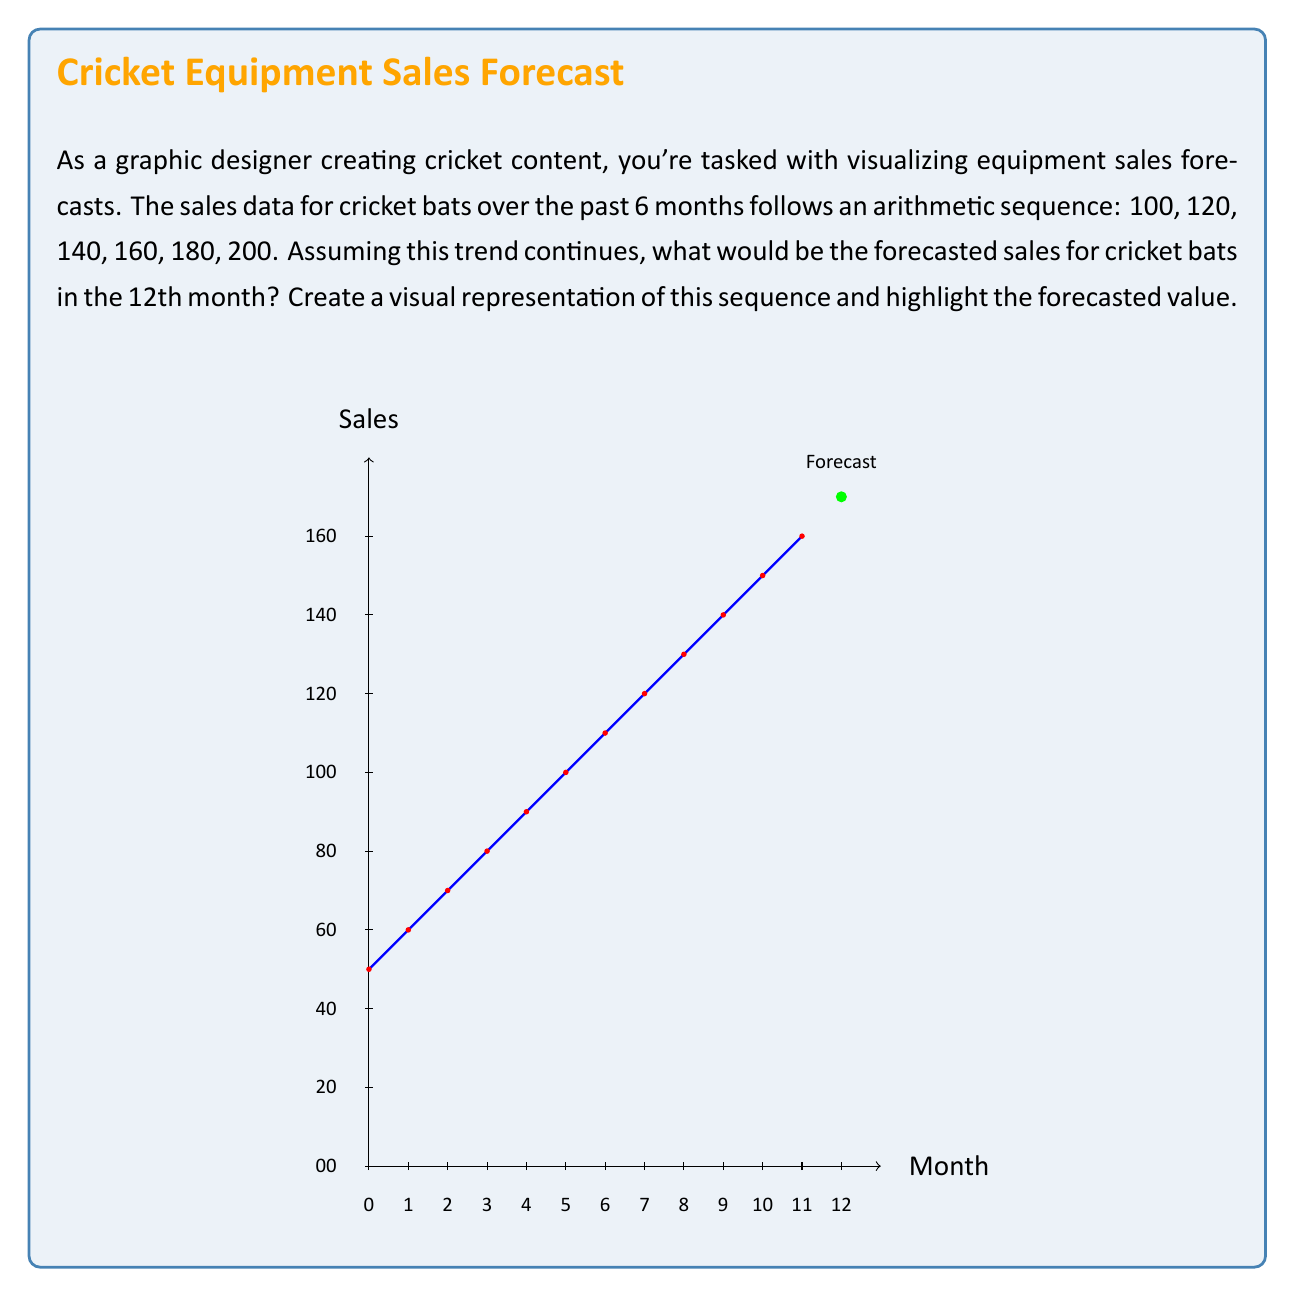Show me your answer to this math problem. To solve this problem, we need to follow these steps:

1) Identify the arithmetic sequence:
   The sequence is 100, 120, 140, 160, 180, 200

2) Calculate the common difference (d):
   $d = 120 - 100 = 140 - 120 = 160 - 140 = 20$

3) Use the arithmetic sequence formula:
   $a_n = a_1 + (n-1)d$
   Where $a_n$ is the nth term, $a_1$ is the first term, n is the position, and d is the common difference.

4) We want the 12th term, so n = 12:
   $a_{12} = 100 + (12-1)20$

5) Simplify:
   $a_{12} = 100 + 11(20)$
   $a_{12} = 100 + 220$
   $a_{12} = 320$

Therefore, the forecasted sales for cricket bats in the 12th month would be 320.
Answer: 320 cricket bats 